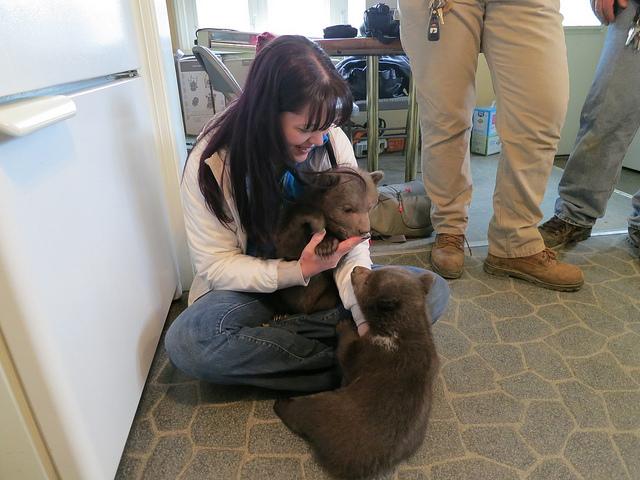Do these animals make good pets?
Write a very short answer. No. What type of animal is the female holding?
Be succinct. Bear. Are these teddy bears?
Concise answer only. No. What is the relation between these cubs?
Be succinct. Siblings. What is the female human doing with the animals?
Keep it brief. Playing. 